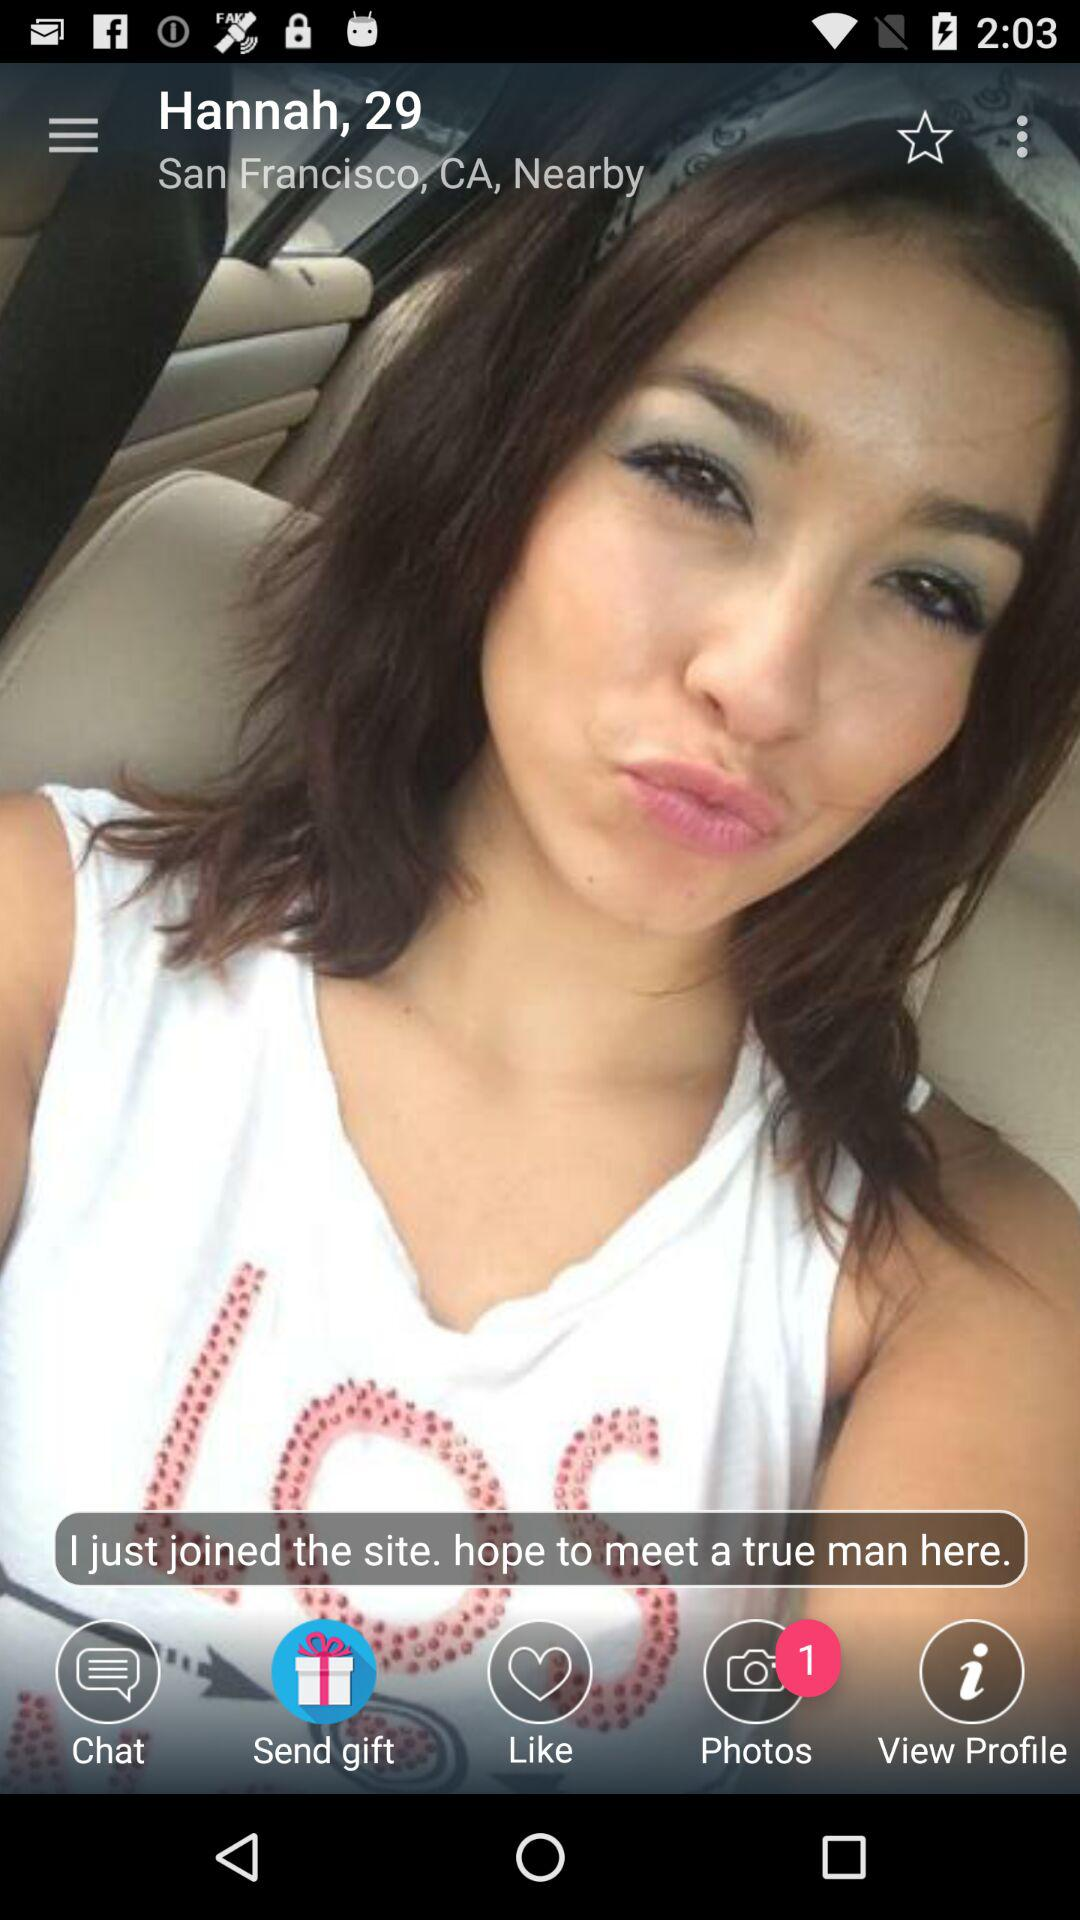How many new pictures are there in the photos? There is 1 new picture. 